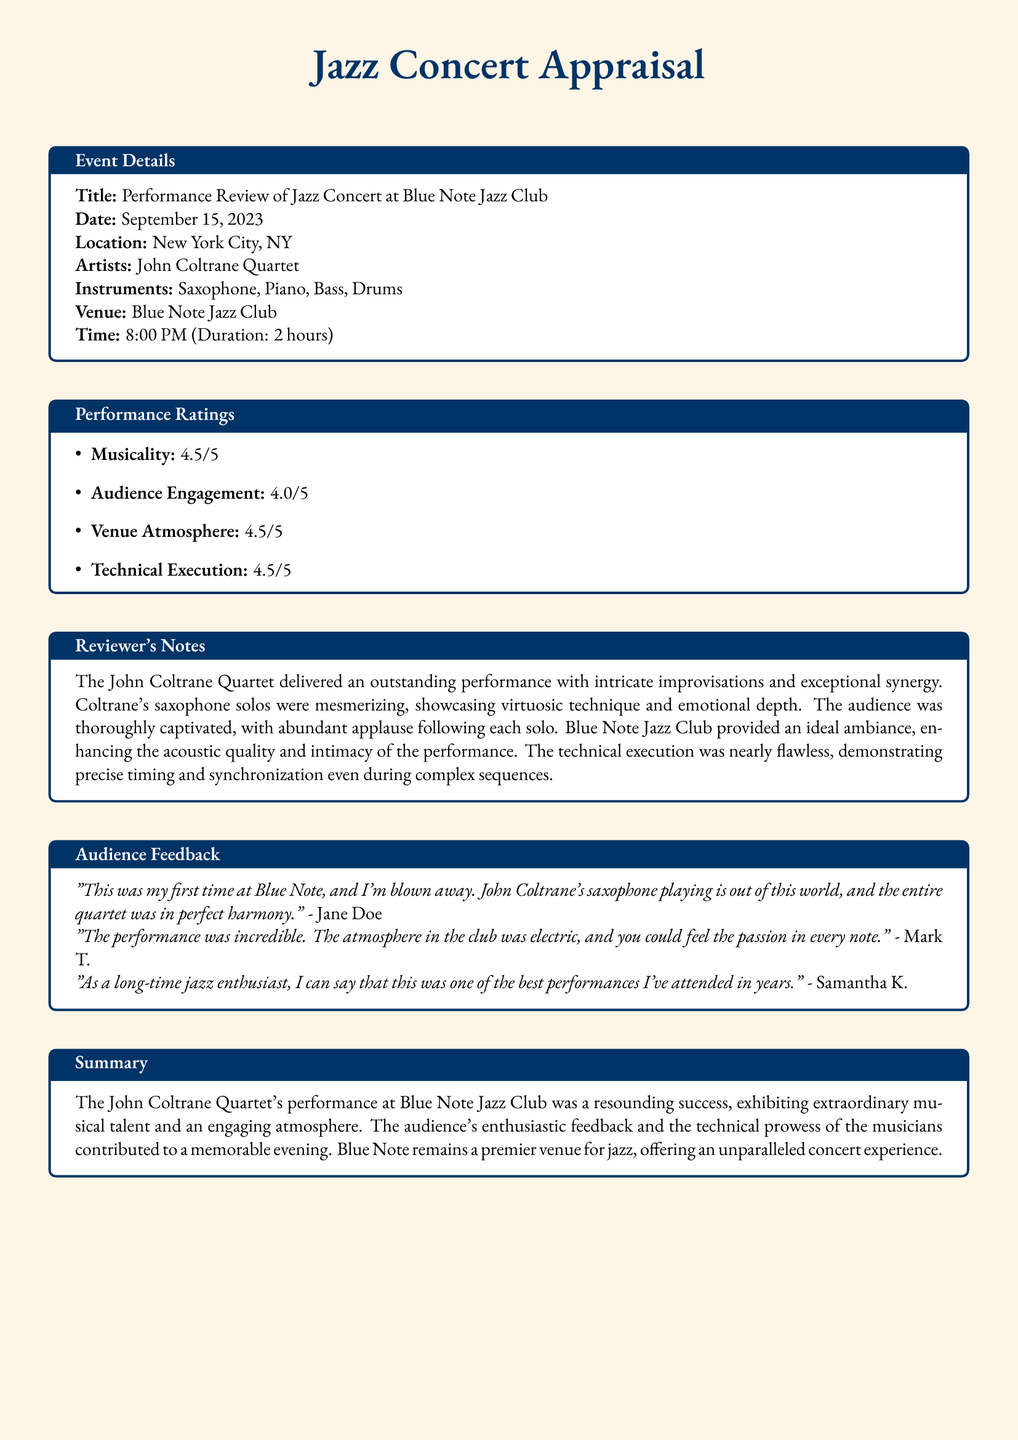what was the date of the concert? The concert date is explicitly stated in the document under Event Details.
Answer: September 15, 2023 who performed at the concert? The name of the performing artist is listed in the document.
Answer: John Coltrane Quartet what was the venue for the performance? The venue where the concert took place is mentioned under Event Details.
Answer: Blue Note Jazz Club what was the audience engagement rating? The performance ratings include specific scores for different aspects, including audience engagement.
Answer: 4.0/5 how long did the concert last? The duration of the concert is stated in the document under Event Details.
Answer: 2 hours which instrument did John Coltrane play? The instruments played during the concert are listed in the Event Details section.
Answer: Saxophone what feedback did Jane Doe provide? One review quote from an audience member is included in the Audience Feedback section.
Answer: "This was my first time at Blue Note, and I'm blown away." how did the reviewer describe the atmosphere at the venue? The Reviewer's Notes provide insights into the atmosphere during the concert.
Answer: Ideal ambiance what was the overall summary of the performance? The Summary section encapsulates the reviewer's opinion on the performance and atmosphere.
Answer: A resounding success 